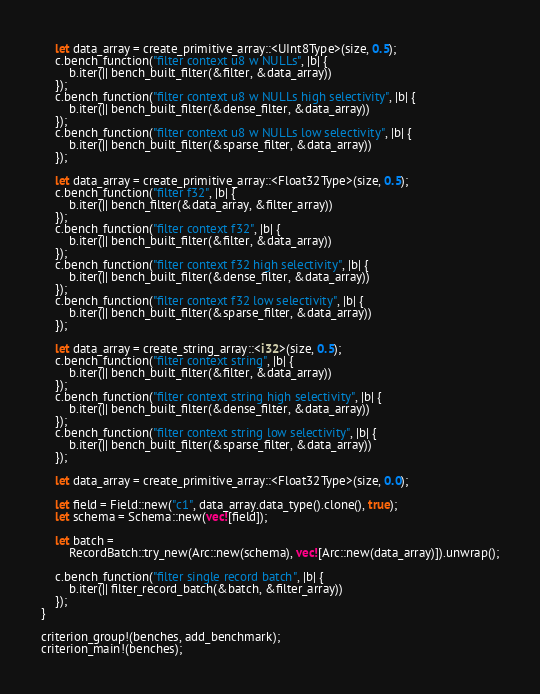Convert code to text. <code><loc_0><loc_0><loc_500><loc_500><_Rust_>    let data_array = create_primitive_array::<UInt8Type>(size, 0.5);
    c.bench_function("filter context u8 w NULLs", |b| {
        b.iter(|| bench_built_filter(&filter, &data_array))
    });
    c.bench_function("filter context u8 w NULLs high selectivity", |b| {
        b.iter(|| bench_built_filter(&dense_filter, &data_array))
    });
    c.bench_function("filter context u8 w NULLs low selectivity", |b| {
        b.iter(|| bench_built_filter(&sparse_filter, &data_array))
    });

    let data_array = create_primitive_array::<Float32Type>(size, 0.5);
    c.bench_function("filter f32", |b| {
        b.iter(|| bench_filter(&data_array, &filter_array))
    });
    c.bench_function("filter context f32", |b| {
        b.iter(|| bench_built_filter(&filter, &data_array))
    });
    c.bench_function("filter context f32 high selectivity", |b| {
        b.iter(|| bench_built_filter(&dense_filter, &data_array))
    });
    c.bench_function("filter context f32 low selectivity", |b| {
        b.iter(|| bench_built_filter(&sparse_filter, &data_array))
    });

    let data_array = create_string_array::<i32>(size, 0.5);
    c.bench_function("filter context string", |b| {
        b.iter(|| bench_built_filter(&filter, &data_array))
    });
    c.bench_function("filter context string high selectivity", |b| {
        b.iter(|| bench_built_filter(&dense_filter, &data_array))
    });
    c.bench_function("filter context string low selectivity", |b| {
        b.iter(|| bench_built_filter(&sparse_filter, &data_array))
    });

    let data_array = create_primitive_array::<Float32Type>(size, 0.0);

    let field = Field::new("c1", data_array.data_type().clone(), true);
    let schema = Schema::new(vec![field]);

    let batch =
        RecordBatch::try_new(Arc::new(schema), vec![Arc::new(data_array)]).unwrap();

    c.bench_function("filter single record batch", |b| {
        b.iter(|| filter_record_batch(&batch, &filter_array))
    });
}

criterion_group!(benches, add_benchmark);
criterion_main!(benches);
</code> 